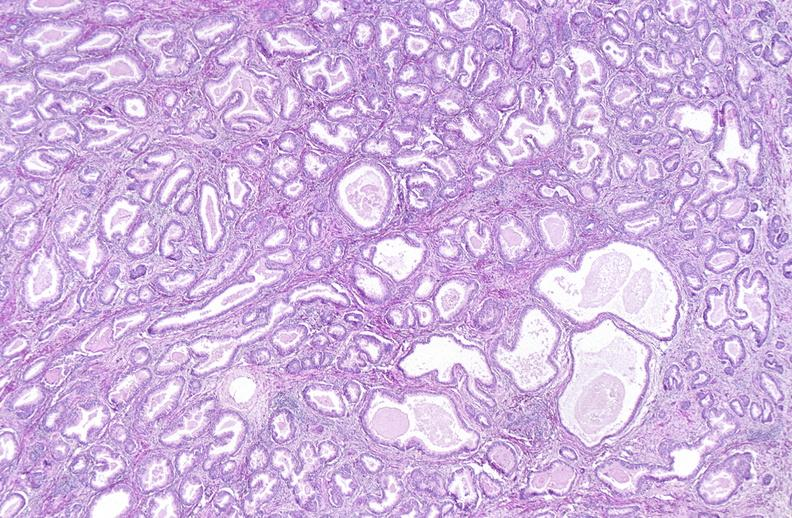what does this image show?
Answer the question using a single word or phrase. Prostate 